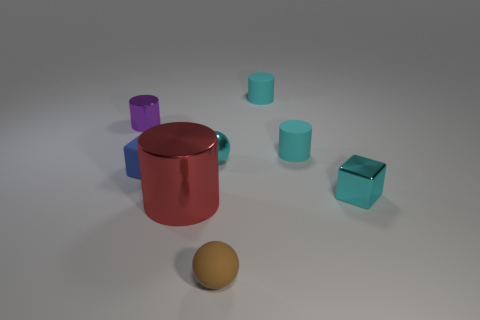Is there a red metallic thing of the same shape as the brown rubber object?
Make the answer very short. No. Is the shape of the small cyan thing that is left of the tiny brown matte ball the same as the object that is in front of the large shiny cylinder?
Make the answer very short. Yes. There is another ball that is the same size as the cyan ball; what material is it?
Your response must be concise. Rubber. How many other objects are there of the same material as the cyan ball?
Offer a very short reply. 3. There is a shiny object in front of the small cube that is to the right of the tiny rubber sphere; what shape is it?
Make the answer very short. Cylinder. How many things are either big yellow things or small matte things that are on the right side of the rubber cube?
Provide a short and direct response. 3. How many other things are there of the same color as the tiny rubber ball?
Ensure brevity in your answer.  0. What number of purple things are small cubes or tiny rubber cylinders?
Your response must be concise. 0. There is a cyan metal object right of the small cyan metal object left of the brown matte thing; are there any small cyan matte objects that are on the right side of it?
Give a very brief answer. No. Is there anything else that is the same size as the red metal thing?
Provide a short and direct response. No. 